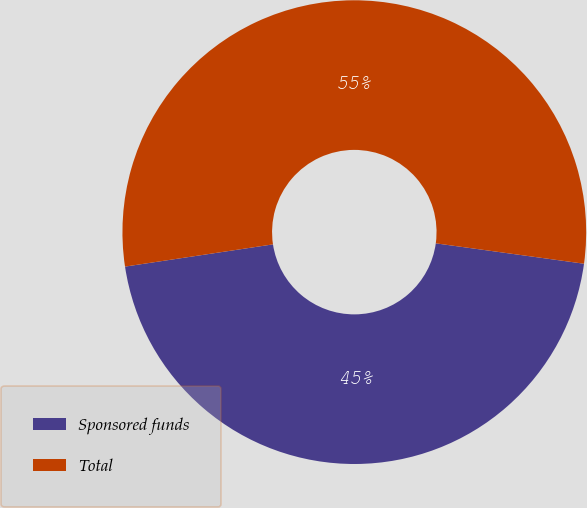Convert chart. <chart><loc_0><loc_0><loc_500><loc_500><pie_chart><fcel>Sponsored funds<fcel>Total<nl><fcel>45.45%<fcel>54.55%<nl></chart> 